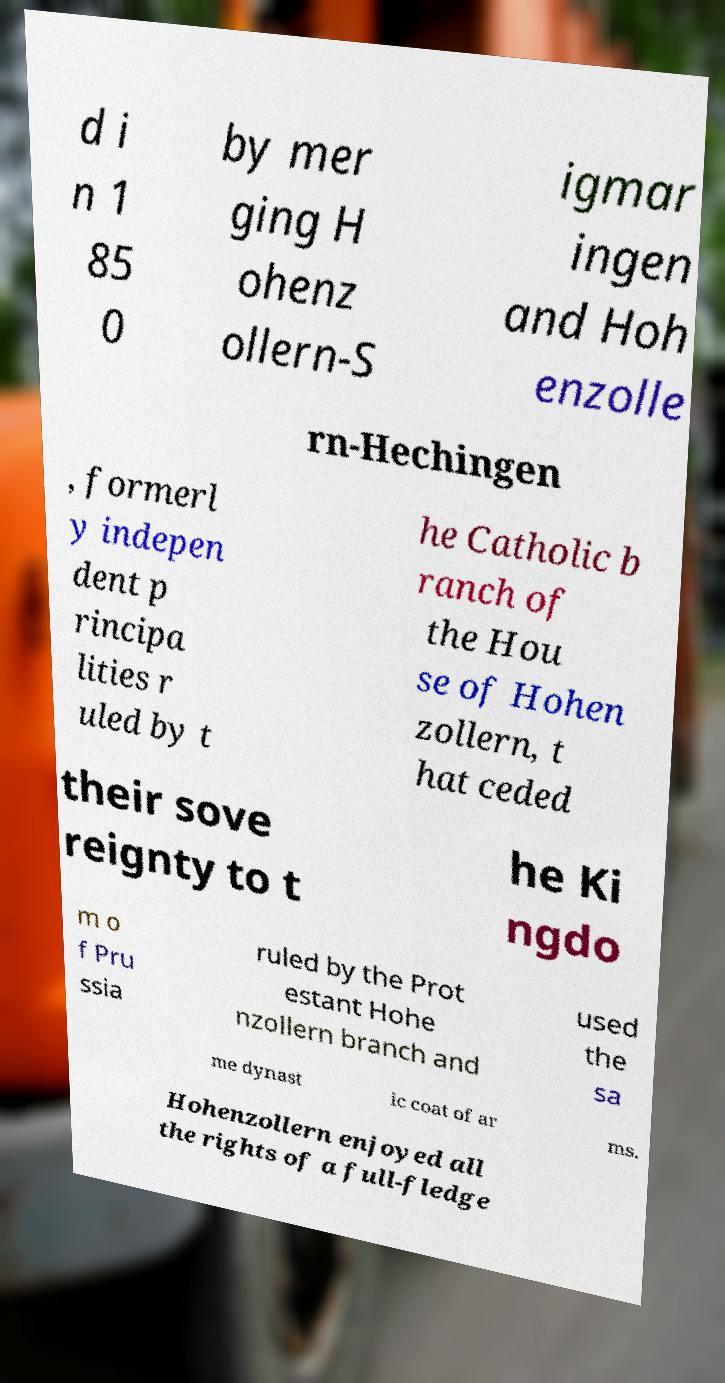Can you accurately transcribe the text from the provided image for me? d i n 1 85 0 by mer ging H ohenz ollern-S igmar ingen and Hoh enzolle rn-Hechingen , formerl y indepen dent p rincipa lities r uled by t he Catholic b ranch of the Hou se of Hohen zollern, t hat ceded their sove reignty to t he Ki ngdo m o f Pru ssia ruled by the Prot estant Hohe nzollern branch and used the sa me dynast ic coat of ar ms. Hohenzollern enjoyed all the rights of a full-fledge 